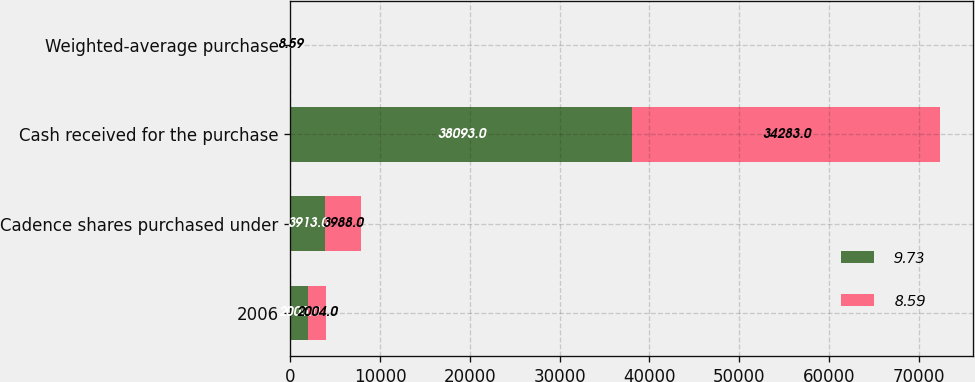Convert chart to OTSL. <chart><loc_0><loc_0><loc_500><loc_500><stacked_bar_chart><ecel><fcel>2006<fcel>Cadence shares purchased under<fcel>Cash received for the purchase<fcel>Weighted-average purchase<nl><fcel>9.73<fcel>2005<fcel>3913<fcel>38093<fcel>9.73<nl><fcel>8.59<fcel>2004<fcel>3988<fcel>34283<fcel>8.59<nl></chart> 